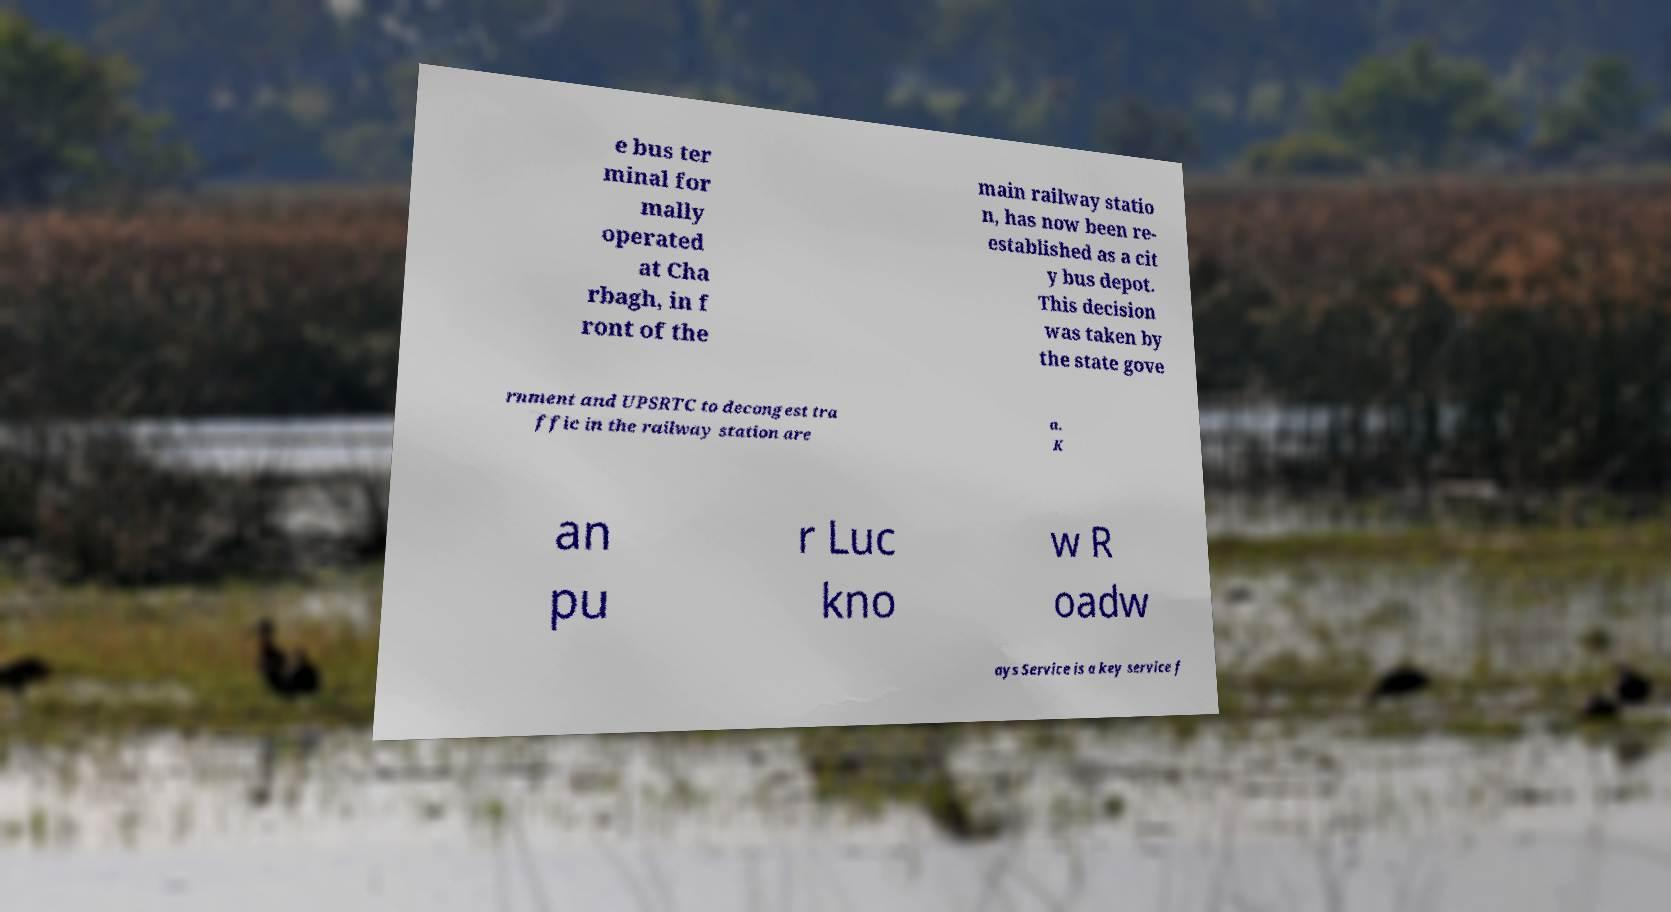Could you assist in decoding the text presented in this image and type it out clearly? e bus ter minal for mally operated at Cha rbagh, in f ront of the main railway statio n, has now been re- established as a cit y bus depot. This decision was taken by the state gove rnment and UPSRTC to decongest tra ffic in the railway station are a. K an pu r Luc kno w R oadw ays Service is a key service f 